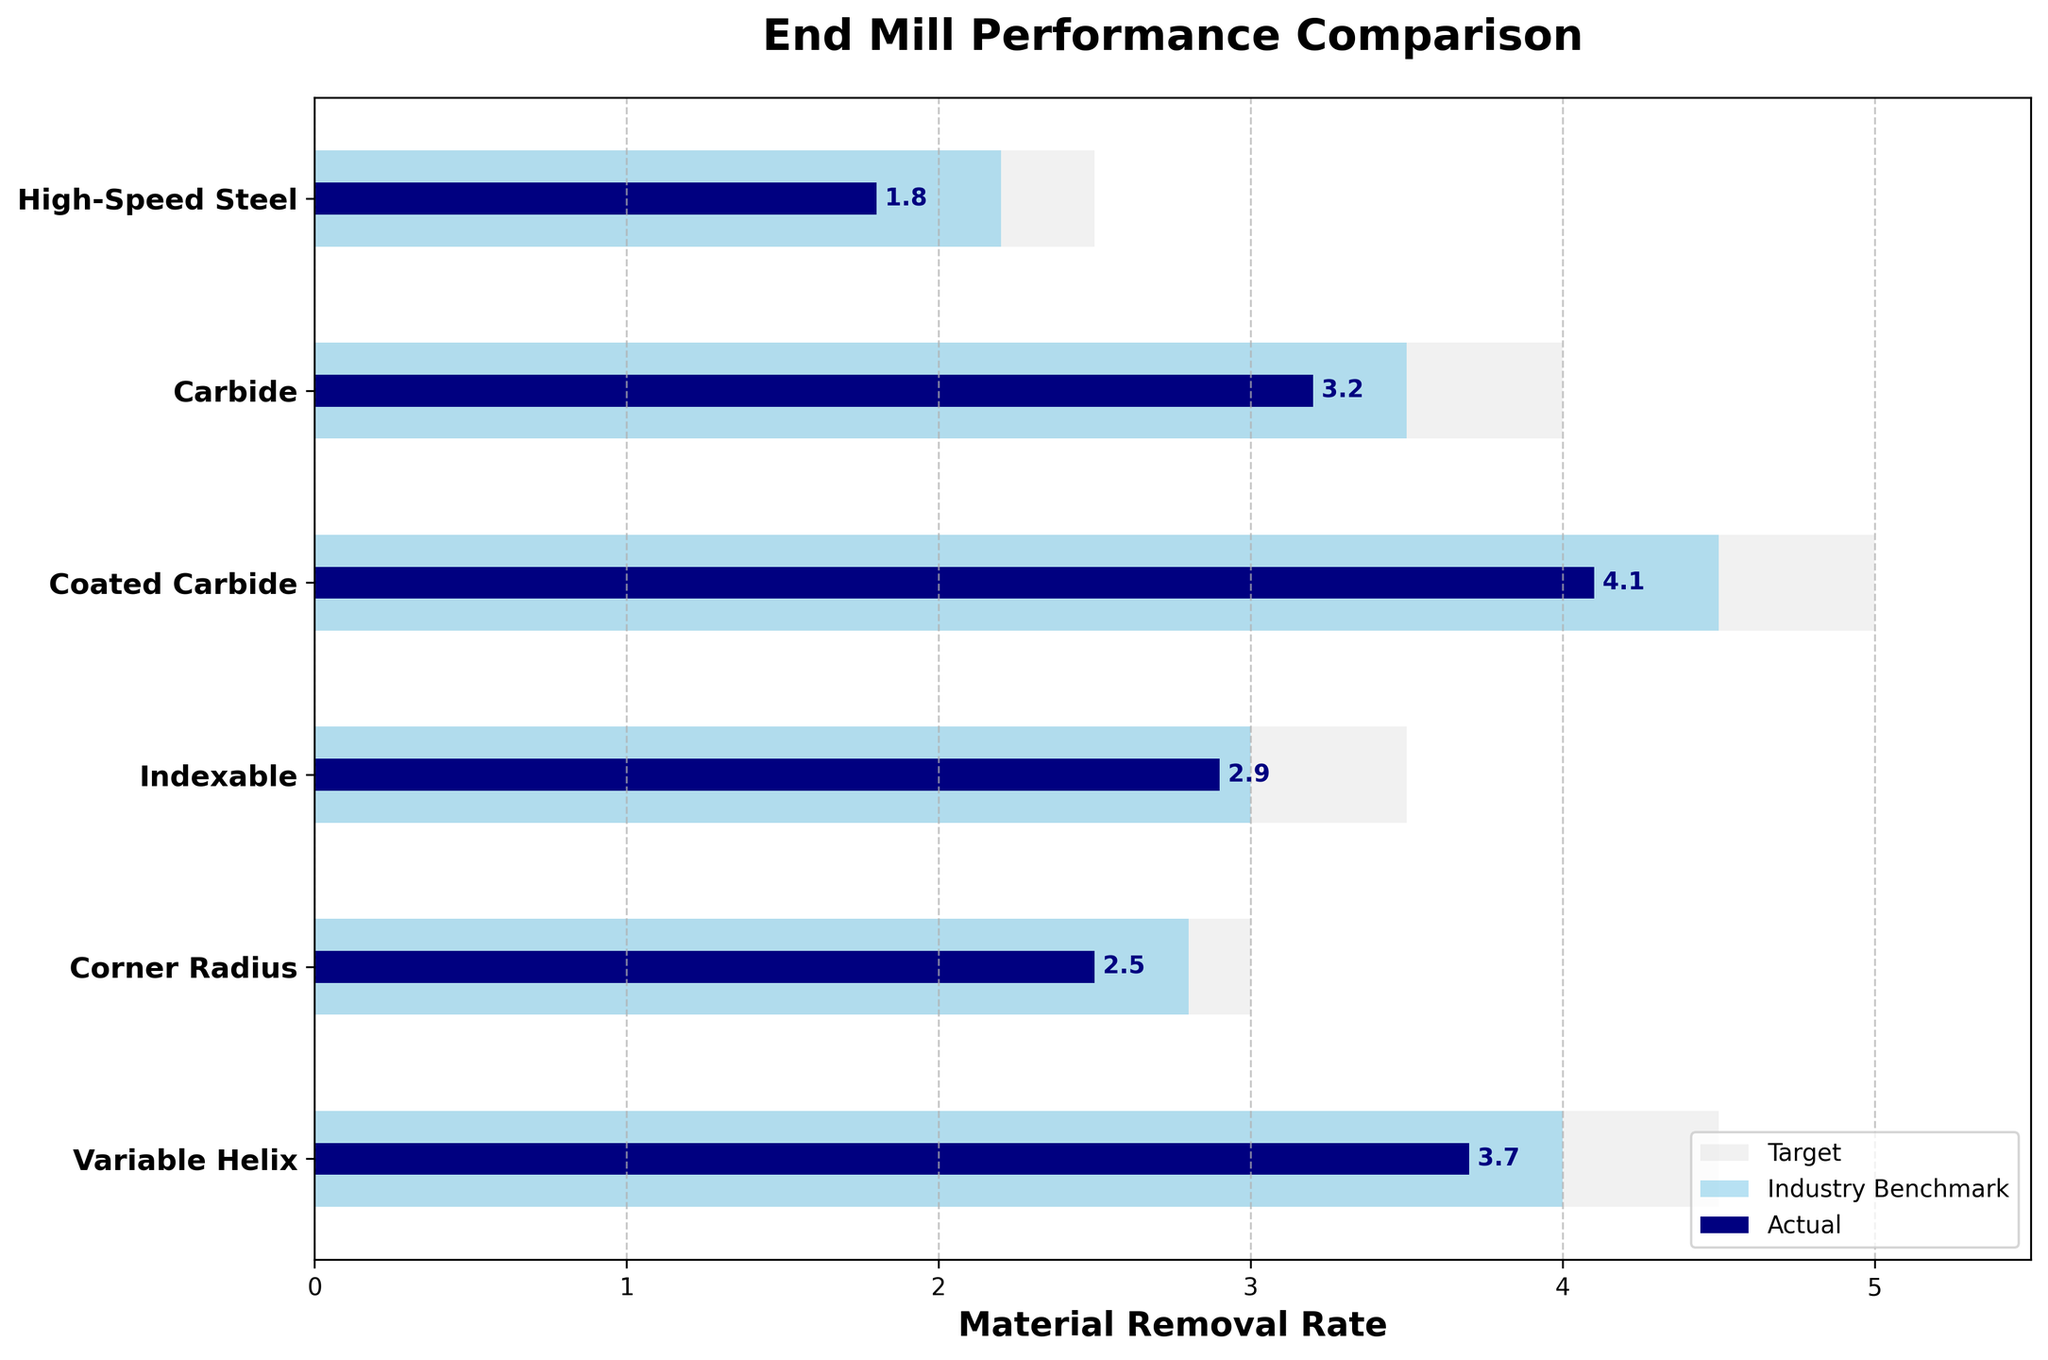what is the highest material removal rate observed for any end mill geometry? The highest material removal rate can be found by looking for the largest value in the "Actual" column in the figure. The "Coated Carbide" category has a rate of 4.1, which is the highest.
Answer: 4.1 what are the three material removal rates shown in the figure? The three material removal rates are the Actual value, the Comparative (Industry Benchmark) value, and the Target value for each end mill geometry. These can be found in the three different bars shown for each category.
Answer: Actual, Comparative, Target how does the material removal rate of Variable Helix compare to the industry benchmark? By observing the bars for the "Variable Helix" category, we see that the Actual rate is 3.7, and the Comparative rate is 4.0. The Actual rate is therefore less than the Comparative (Industry Benchmark) rate.
Answer: Less than which end mill geometry is closest to reaching its target? To find the closest to target, compare the Actual and Target values for each category. "High-Speed Steel" has the smallest difference of 2.5 - 1.8 = 0.7, making it the closest to reaching its target.
Answer: High-Speed Steel which end mill geometry exceeds its industry benchmark but falls short of its target? Compare the Actual and Comparative values for each category, then check if any category exceeds the Comparative but is less than the Target. "Indexable" has Actual = 2.9, Comparative = 3.0 (exceeds), and Target = 3.5 (falls short).
Answer: Indexable what is the difference between the target and the actual material removal rate for carbide? Subtract the Actual value from the Target value for the "Carbide" category. The calculation is 4.0 - 3.2 = 0.8.
Answer: 0.8 which category has the widest gap between actual and target material removal rates? Find the differences between Actual and Target values for each category. The largest difference is for "Coated Carbide," with 5.0 - 4.1 = 0.9.
Answer: Coated Carbide 